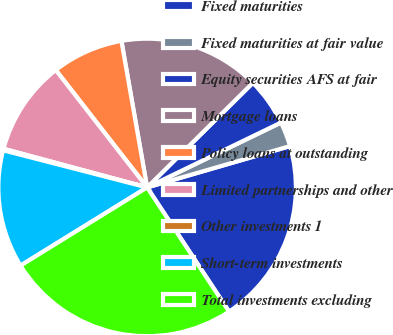Convert chart to OTSL. <chart><loc_0><loc_0><loc_500><loc_500><pie_chart><fcel>Fixed maturities<fcel>Fixed maturities at fair value<fcel>Equity securities AFS at fair<fcel>Mortgage loans<fcel>Policy loans at outstanding<fcel>Limited partnerships and other<fcel>Other investments 1<fcel>Short-term investments<fcel>Total investments excluding<nl><fcel>20.2%<fcel>2.7%<fcel>5.23%<fcel>15.35%<fcel>7.76%<fcel>10.29%<fcel>0.17%<fcel>12.82%<fcel>25.48%<nl></chart> 